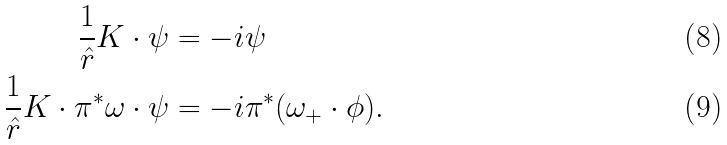Convert formula to latex. <formula><loc_0><loc_0><loc_500><loc_500>\frac { 1 } { \hat { r } } K \cdot \psi & = - i \psi \\ \frac { 1 } { \hat { r } } K \cdot \pi ^ { * } \omega \cdot \psi & = - i \pi ^ { * } ( \omega _ { + } \cdot \phi ) .</formula> 